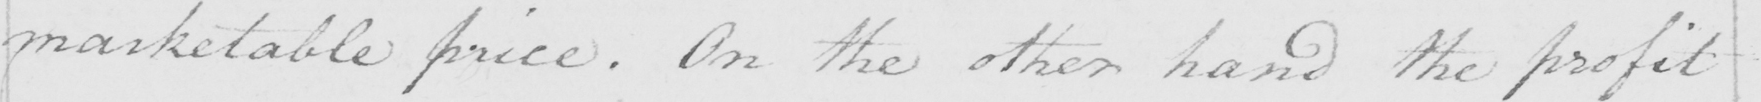Please provide the text content of this handwritten line. marketable price . On the other hand the profit 